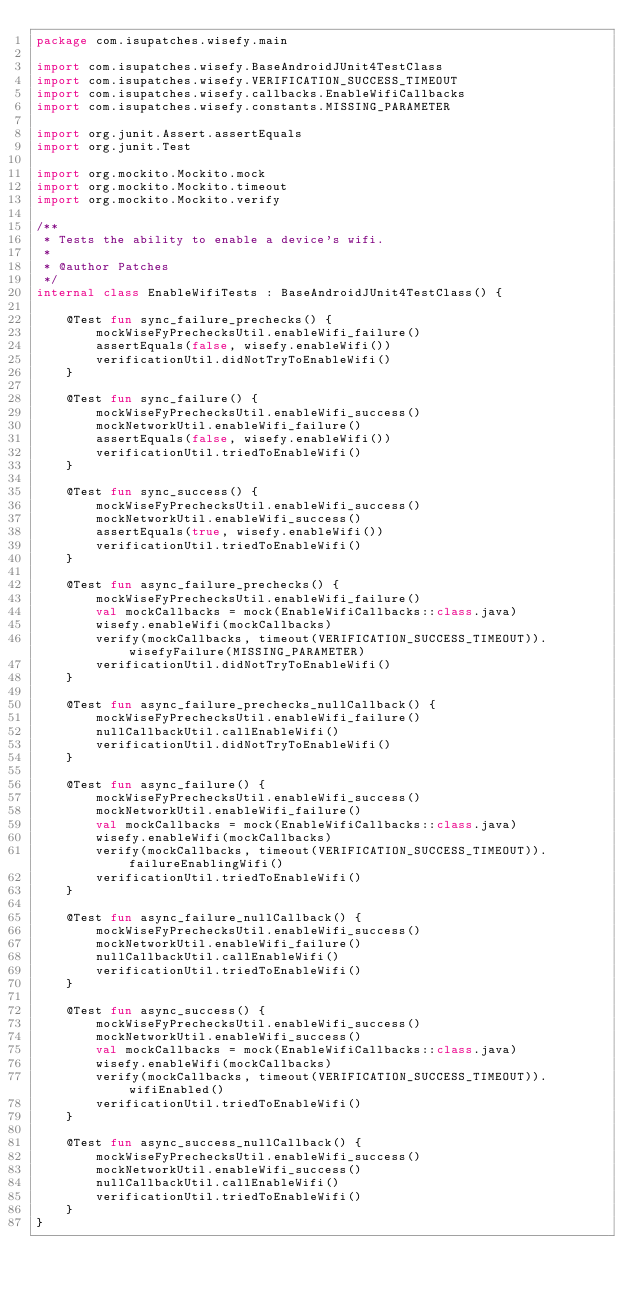<code> <loc_0><loc_0><loc_500><loc_500><_Kotlin_>package com.isupatches.wisefy.main

import com.isupatches.wisefy.BaseAndroidJUnit4TestClass
import com.isupatches.wisefy.VERIFICATION_SUCCESS_TIMEOUT
import com.isupatches.wisefy.callbacks.EnableWifiCallbacks
import com.isupatches.wisefy.constants.MISSING_PARAMETER

import org.junit.Assert.assertEquals
import org.junit.Test

import org.mockito.Mockito.mock
import org.mockito.Mockito.timeout
import org.mockito.Mockito.verify

/**
 * Tests the ability to enable a device's wifi.
 *
 * @author Patches
 */
internal class EnableWifiTests : BaseAndroidJUnit4TestClass() {

    @Test fun sync_failure_prechecks() {
        mockWiseFyPrechecksUtil.enableWifi_failure()
        assertEquals(false, wisefy.enableWifi())
        verificationUtil.didNotTryToEnableWifi()
    }

    @Test fun sync_failure() {
        mockWiseFyPrechecksUtil.enableWifi_success()
        mockNetworkUtil.enableWifi_failure()
        assertEquals(false, wisefy.enableWifi())
        verificationUtil.triedToEnableWifi()
    }

    @Test fun sync_success() {
        mockWiseFyPrechecksUtil.enableWifi_success()
        mockNetworkUtil.enableWifi_success()
        assertEquals(true, wisefy.enableWifi())
        verificationUtil.triedToEnableWifi()
    }

    @Test fun async_failure_prechecks() {
        mockWiseFyPrechecksUtil.enableWifi_failure()
        val mockCallbacks = mock(EnableWifiCallbacks::class.java)
        wisefy.enableWifi(mockCallbacks)
        verify(mockCallbacks, timeout(VERIFICATION_SUCCESS_TIMEOUT)).wisefyFailure(MISSING_PARAMETER)
        verificationUtil.didNotTryToEnableWifi()
    }

    @Test fun async_failure_prechecks_nullCallback() {
        mockWiseFyPrechecksUtil.enableWifi_failure()
        nullCallbackUtil.callEnableWifi()
        verificationUtil.didNotTryToEnableWifi()
    }

    @Test fun async_failure() {
        mockWiseFyPrechecksUtil.enableWifi_success()
        mockNetworkUtil.enableWifi_failure()
        val mockCallbacks = mock(EnableWifiCallbacks::class.java)
        wisefy.enableWifi(mockCallbacks)
        verify(mockCallbacks, timeout(VERIFICATION_SUCCESS_TIMEOUT)).failureEnablingWifi()
        verificationUtil.triedToEnableWifi()
    }

    @Test fun async_failure_nullCallback() {
        mockWiseFyPrechecksUtil.enableWifi_success()
        mockNetworkUtil.enableWifi_failure()
        nullCallbackUtil.callEnableWifi()
        verificationUtil.triedToEnableWifi()
    }

    @Test fun async_success() {
        mockWiseFyPrechecksUtil.enableWifi_success()
        mockNetworkUtil.enableWifi_success()
        val mockCallbacks = mock(EnableWifiCallbacks::class.java)
        wisefy.enableWifi(mockCallbacks)
        verify(mockCallbacks, timeout(VERIFICATION_SUCCESS_TIMEOUT)).wifiEnabled()
        verificationUtil.triedToEnableWifi()
    }

    @Test fun async_success_nullCallback() {
        mockWiseFyPrechecksUtil.enableWifi_success()
        mockNetworkUtil.enableWifi_success()
        nullCallbackUtil.callEnableWifi()
        verificationUtil.triedToEnableWifi()
    }
}
</code> 